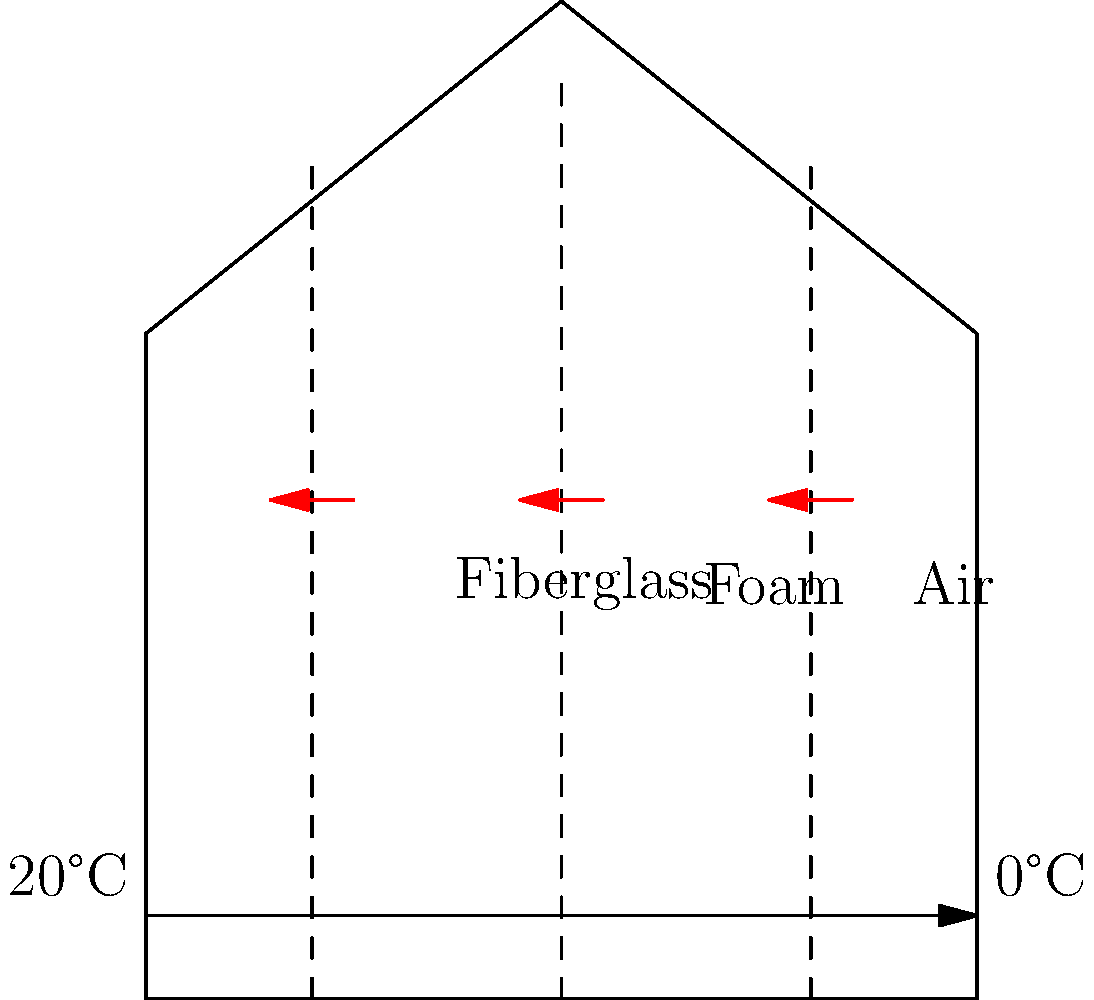As a bed and breakfast owner, you're considering upgrading your property's insulation to reduce heating costs. The diagram shows three wall sections with different insulation materials: fiberglass, foam, and air. If the indoor temperature is 20°C and the outdoor temperature is 0°C, which insulation material would be most effective in reducing heat loss, assuming all other factors are equal? To determine the most effective insulation material, we need to consider the thermal conductivity (k) of each material. The lower the k-value, the better the insulation properties. Let's analyze each material:

1. Fiberglass:
   - Typical k-value: 0.030-0.040 W/(m·K)
   - Good insulator, widely used in construction

2. Foam (assuming polyurethane foam):
   - Typical k-value: 0.022-0.028 W/(m·K)
   - Excellent insulator, lower k-value than fiberglass

3. Air:
   - Typical k-value: 0.024-0.026 W/(m·K) (still air)
   - Good insulator, but prone to convection currents

The heat flux (q) through a material is given by Fourier's law:

$$ q = -k \frac{dT}{dx} $$

Where:
- q is the heat flux (W/m²)
- k is the thermal conductivity (W/(m·K))
- dT/dx is the temperature gradient (K/m)

Given the same temperature difference (20°C - 0°C = 20°C) and assuming equal thicknesses, the material with the lowest k-value will have the lowest heat flux and, therefore, the best insulation properties.

Comparing the k-values:
- Foam has the lowest k-value range (0.022-0.028 W/(m·K))
- Air is next (0.024-0.026 W/(m·K)), but is less practical due to convection
- Fiberglass has the highest k-value range (0.030-0.040 W/(m·K))

Therefore, foam insulation would be the most effective in reducing heat loss under these conditions.
Answer: Foam insulation 